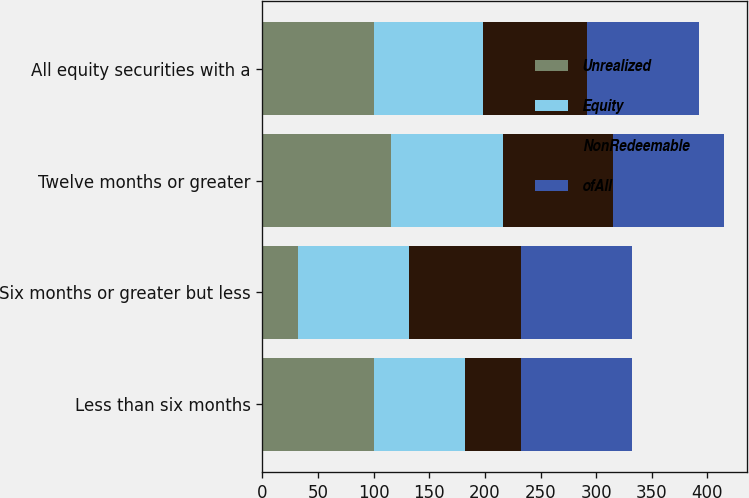<chart> <loc_0><loc_0><loc_500><loc_500><stacked_bar_chart><ecel><fcel>Less than six months<fcel>Six months or greater but less<fcel>Twelve months or greater<fcel>All equity securities with a<nl><fcel>Unrealized<fcel>100<fcel>32<fcel>116<fcel>100<nl><fcel>Equity<fcel>82<fcel>100<fcel>100<fcel>98<nl><fcel>NonRedeemable<fcel>50<fcel>100<fcel>99<fcel>94<nl><fcel>ofAll<fcel>100<fcel>100<fcel>100<fcel>100<nl></chart> 